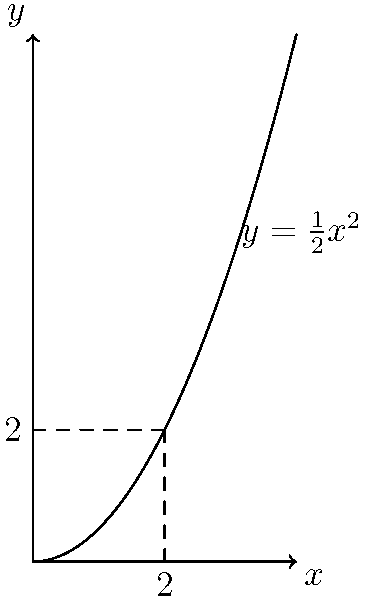A small object moves along the curve $y=\frac{1}{2}x^2$ from $x=0$ to $x=2$. A constant force of 10 N acts on the object in the positive x-direction throughout its motion. Calculate the work done by this force on the object. To solve this problem, we need to follow these steps:

1) The work done by a force along a curved path is given by the line integral:

   $$W = \int_C \vec{F} \cdot d\vec{r}$$

2) In this case, the force is constant and only in the x-direction, so $\vec{F} = 10\hat{i}$ N.

3) The displacement vector $d\vec{r}$ can be written as $dx\hat{i} + dy\hat{j}$.

4) Substituting these into the work equation:

   $$W = \int_C (10\hat{i}) \cdot (dx\hat{i} + dy\hat{j})$$

5) Simplifying the dot product:

   $$W = \int_C 10 dx$$

6) The limits of integration are from $x=0$ to $x=2$:

   $$W = \int_0^2 10 dx$$

7) Evaluating the integral:

   $$W = 10x \Big|_0^2 = 10(2) - 10(0) = 20\text{ J}$$

Therefore, the work done by the force is 20 Joules.
Answer: 20 J 